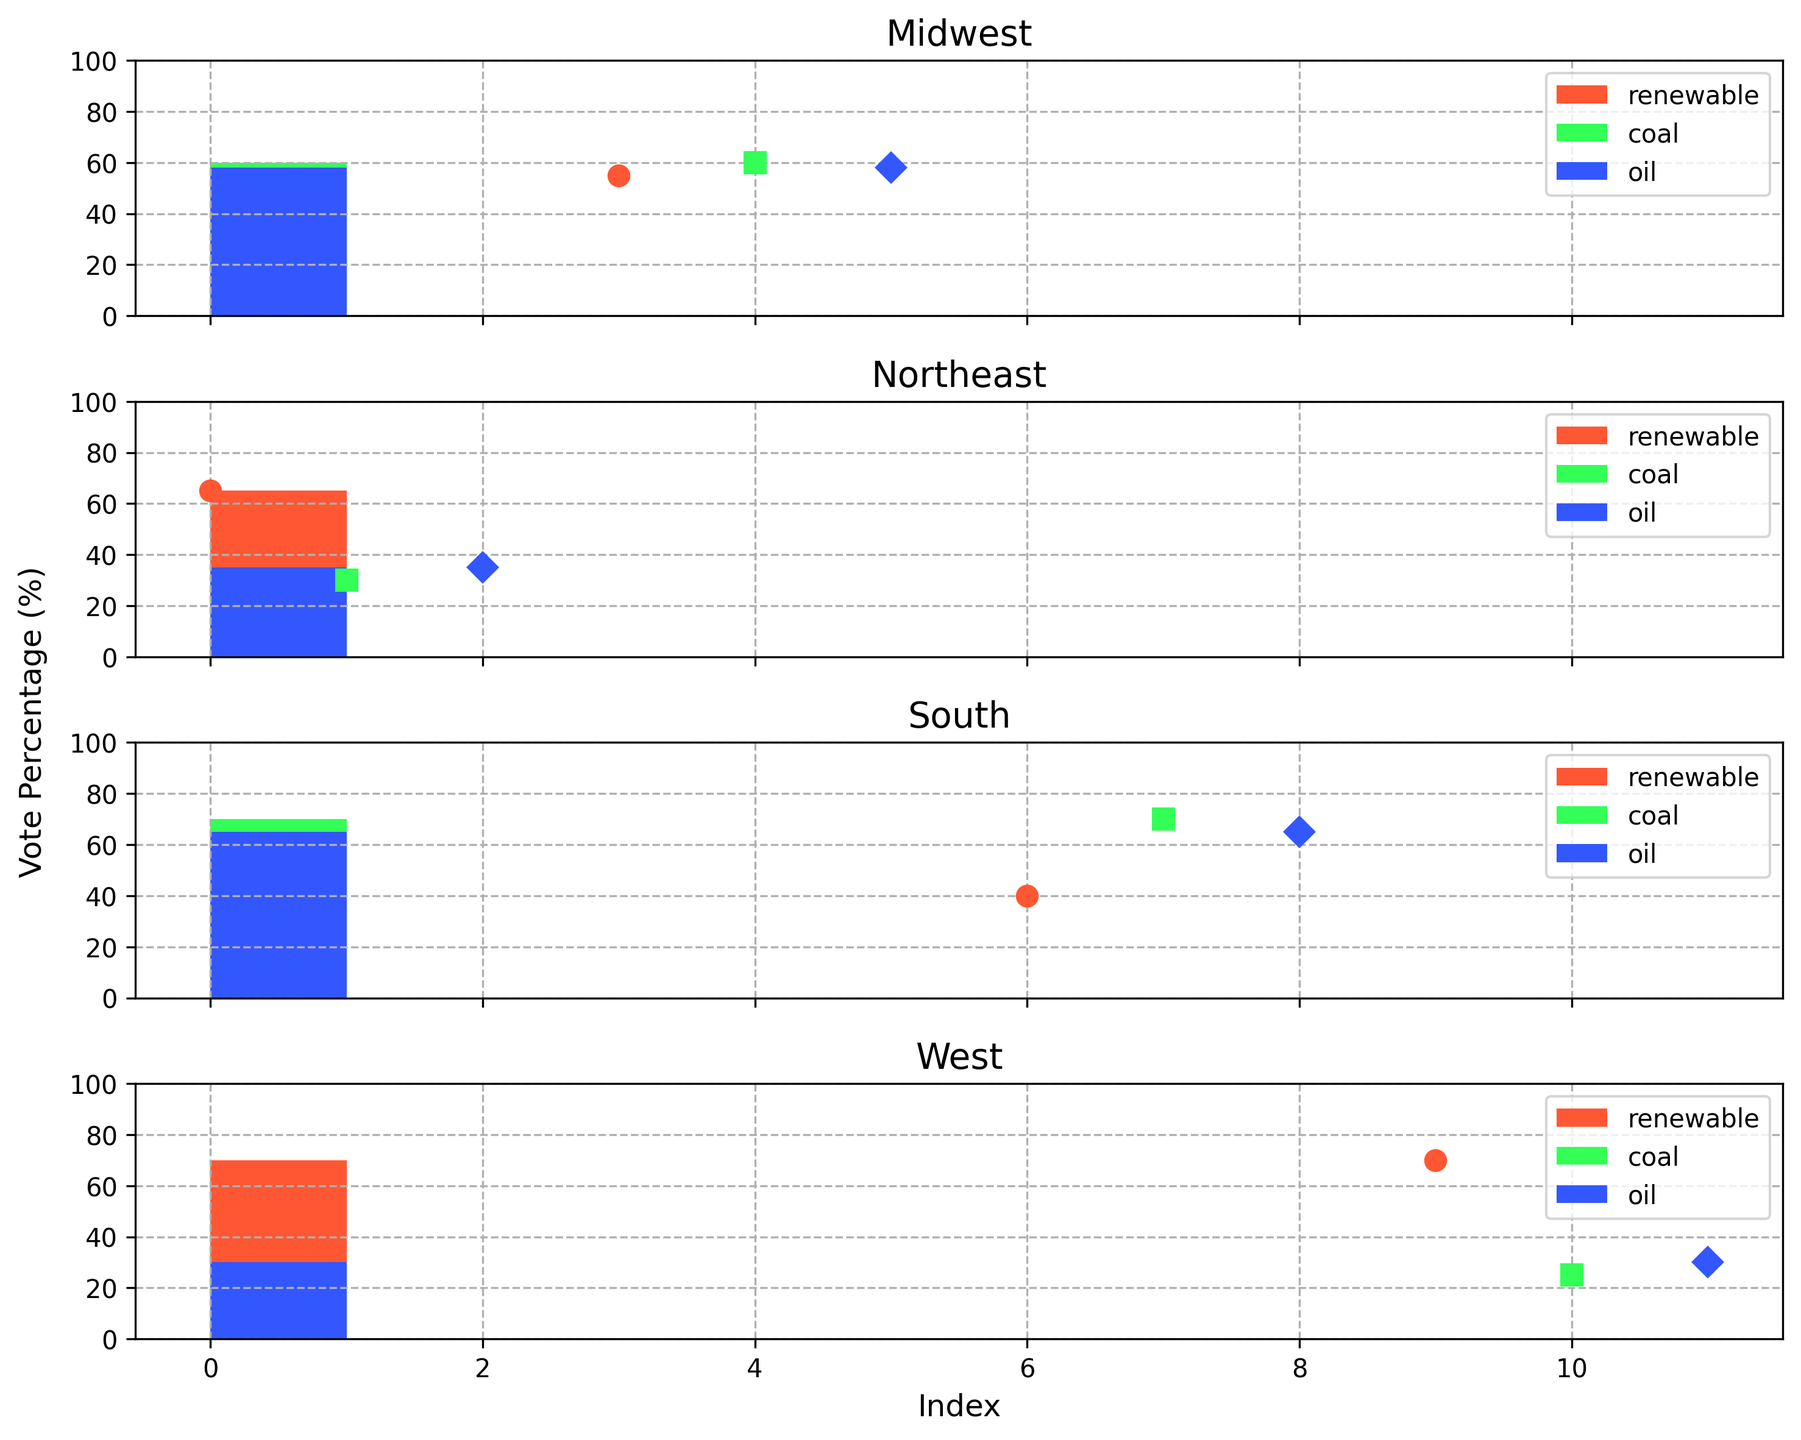What percentage of votes in the Midwest are associated with coal? Look at the Midwest region and find the bar representing coal. The height of this bar indicates the vote percentage for coal in the Midwest.
Answer: 60 Which industry has the highest vote percentage in the Northeast? Compare the heights of the bars for renewable, coal, and oil in the Northeast. The tallest bar indicates the highest vote percentage.
Answer: Renewable What is the total vote percentage for coal and oil in the South? Add the vote percentages for coal and oil in the South. These values are 70% for coal and 65% for oil. 70 + 65 = 135
Answer: 135 How does the vote percentage for renewable energy in the West compare to that in the South? Look at the heights of the bars representing renewable energy in both the West and the South. Compare these heights to see which is higher.
Answer: West is higher What is the average vote percentage for oil across all regions? Find the vote percentages for oil in all regions: Northeast (35), Midwest (58), South (65), and West (30). Add these values and divide by the number of regions. (35 + 58 + 65 + 30) / 4 = 188 / 4 = 47
Answer: 47 Which region has the lowest vote percentage for coal? Compare the heights of the bars representing coal in all regions. The shortest bar indicates the lowest vote percentage.
Answer: West Are there any regions where the vote percentage for renewable energy exceeds 60%? Check the heights of the bars representing renewable energy across all regions. See if any of these heights surpass the 60% mark.
Answer: Yes In which region is the difference between the vote percentages for coal and renewable energy the largest? Calculate the difference between vote percentages for coal and renewable energy in each region: Northeast (30 - 65 = -35), Midwest (60 - 55 = 5), South (70 - 40 = 30), West (25 - 70 = -45). The largest absolute difference is in the West.
Answer: West Is the vote percentage for coal higher in the Midwest or the South? Compare the heights of the bars representing coal in the Midwest and the South. The taller bar indicates a higher vote percentage.
Answer: South What is the combined vote percentage for the renewable industry in the Northeast and West regions? Add the vote percentages for the renewable industry in the Northeast and West regions: 65% for Northeast and 70% for West. 65 + 70 = 135
Answer: 135 